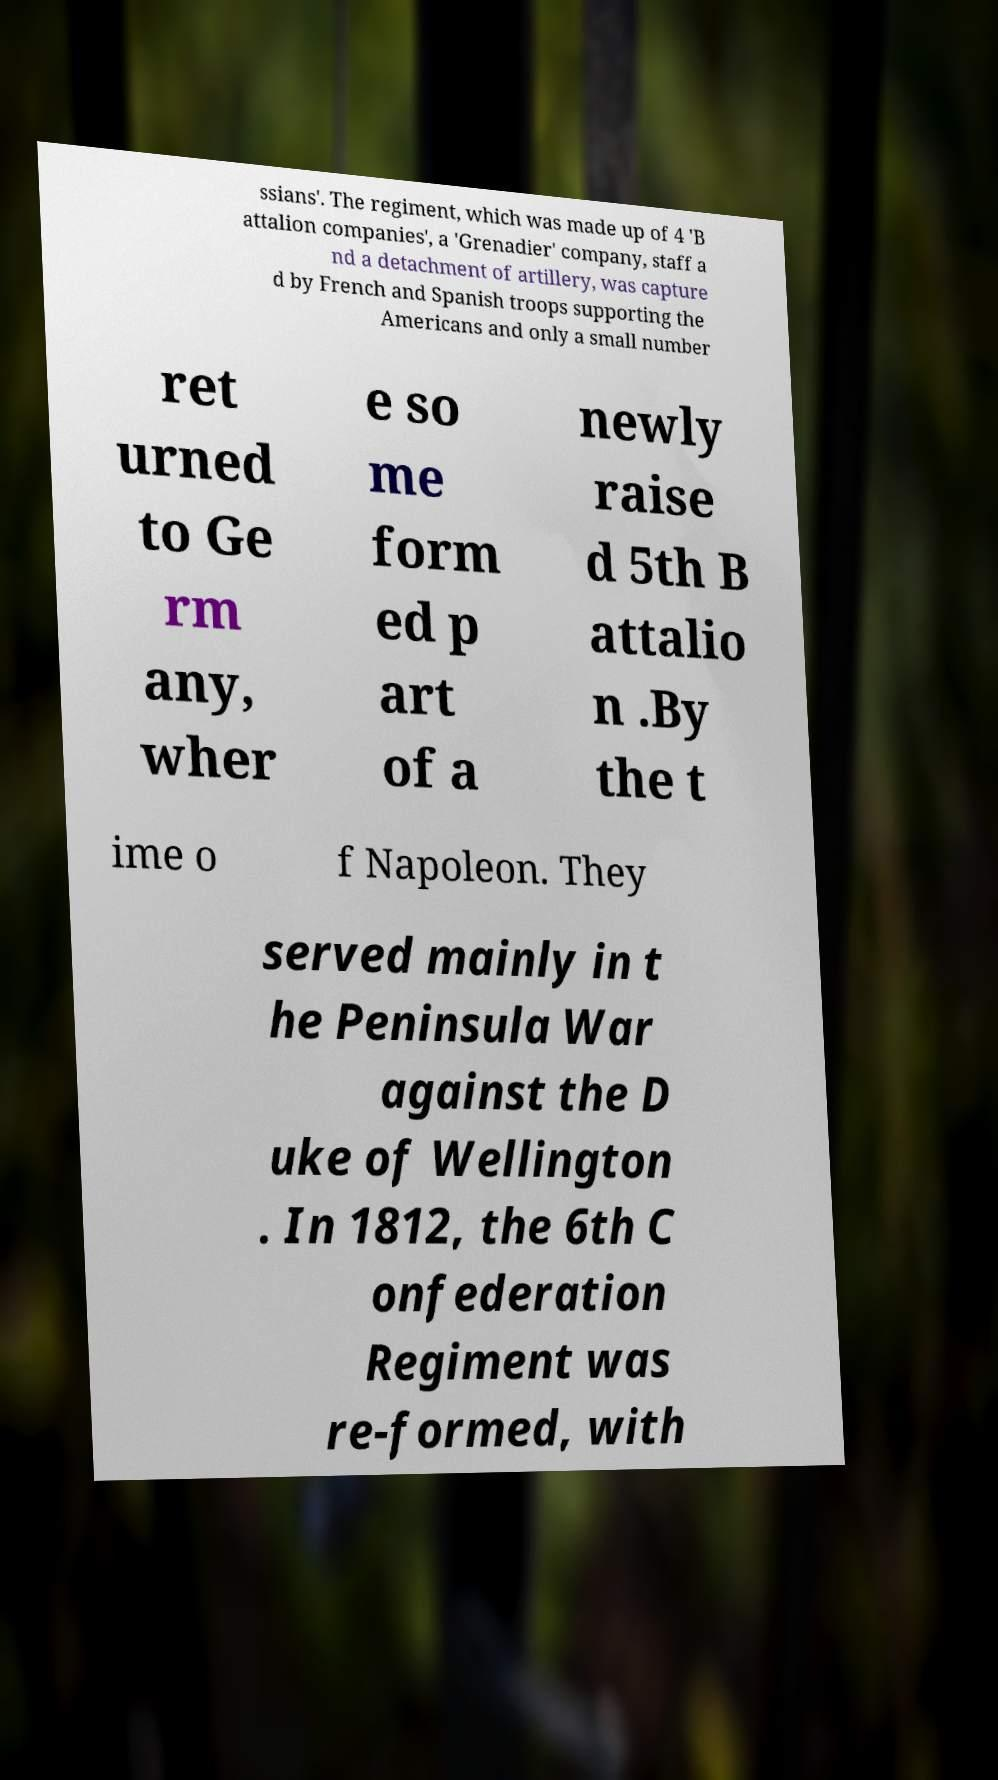What messages or text are displayed in this image? I need them in a readable, typed format. ssians'. The regiment, which was made up of 4 'B attalion companies', a 'Grenadier' company, staff a nd a detachment of artillery, was capture d by French and Spanish troops supporting the Americans and only a small number ret urned to Ge rm any, wher e so me form ed p art of a newly raise d 5th B attalio n .By the t ime o f Napoleon. They served mainly in t he Peninsula War against the D uke of Wellington . In 1812, the 6th C onfederation Regiment was re-formed, with 